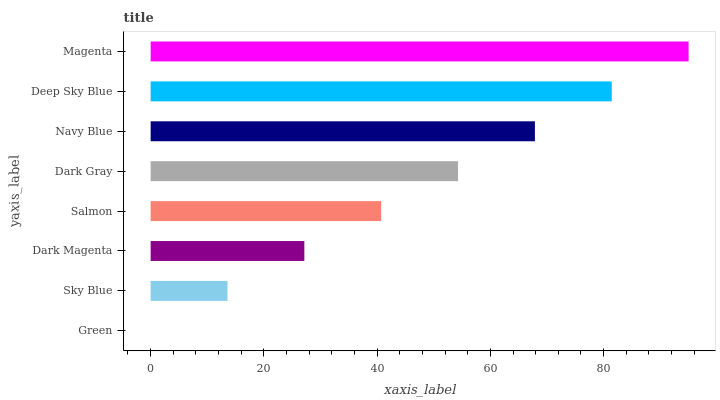Is Green the minimum?
Answer yes or no. Yes. Is Magenta the maximum?
Answer yes or no. Yes. Is Sky Blue the minimum?
Answer yes or no. No. Is Sky Blue the maximum?
Answer yes or no. No. Is Sky Blue greater than Green?
Answer yes or no. Yes. Is Green less than Sky Blue?
Answer yes or no. Yes. Is Green greater than Sky Blue?
Answer yes or no. No. Is Sky Blue less than Green?
Answer yes or no. No. Is Dark Gray the high median?
Answer yes or no. Yes. Is Salmon the low median?
Answer yes or no. Yes. Is Green the high median?
Answer yes or no. No. Is Navy Blue the low median?
Answer yes or no. No. 